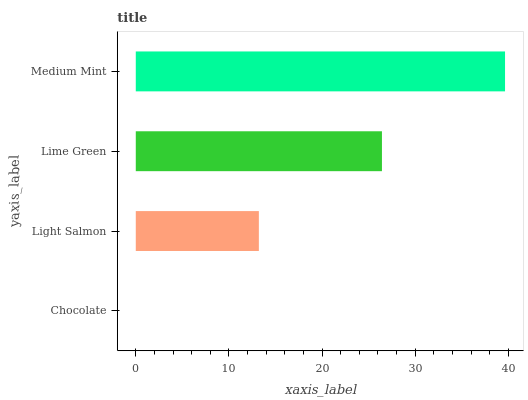Is Chocolate the minimum?
Answer yes or no. Yes. Is Medium Mint the maximum?
Answer yes or no. Yes. Is Light Salmon the minimum?
Answer yes or no. No. Is Light Salmon the maximum?
Answer yes or no. No. Is Light Salmon greater than Chocolate?
Answer yes or no. Yes. Is Chocolate less than Light Salmon?
Answer yes or no. Yes. Is Chocolate greater than Light Salmon?
Answer yes or no. No. Is Light Salmon less than Chocolate?
Answer yes or no. No. Is Lime Green the high median?
Answer yes or no. Yes. Is Light Salmon the low median?
Answer yes or no. Yes. Is Chocolate the high median?
Answer yes or no. No. Is Lime Green the low median?
Answer yes or no. No. 